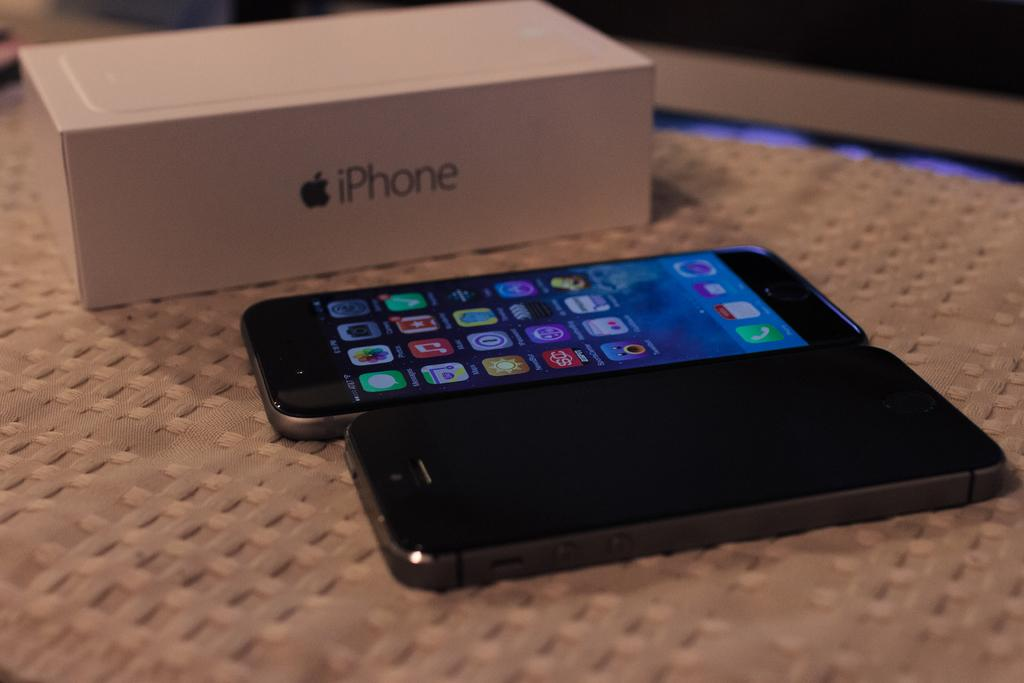<image>
Give a short and clear explanation of the subsequent image. A white iphone cellphone box beside two smart phones 